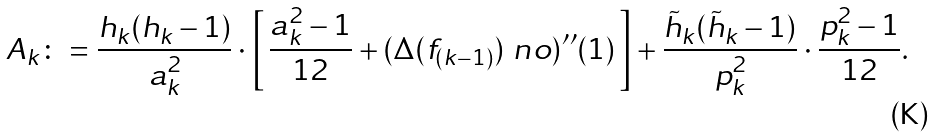Convert formula to latex. <formula><loc_0><loc_0><loc_500><loc_500>A _ { k } \colon = \frac { h _ { k } ( h _ { k } - 1 ) } { a _ { k } ^ { 2 } } \cdot \left [ \, \frac { a _ { k } ^ { 2 } - 1 } { 1 2 } + ( \Delta ( f _ { ( k - 1 ) } ) ^ { \ } n o ) ^ { \prime \prime } ( 1 ) \, \right ] + \frac { \tilde { h } _ { k } ( \tilde { h } _ { k } - 1 ) } { p _ { k } ^ { 2 } } \cdot \frac { p _ { k } ^ { 2 } - 1 } { 1 2 } .</formula> 